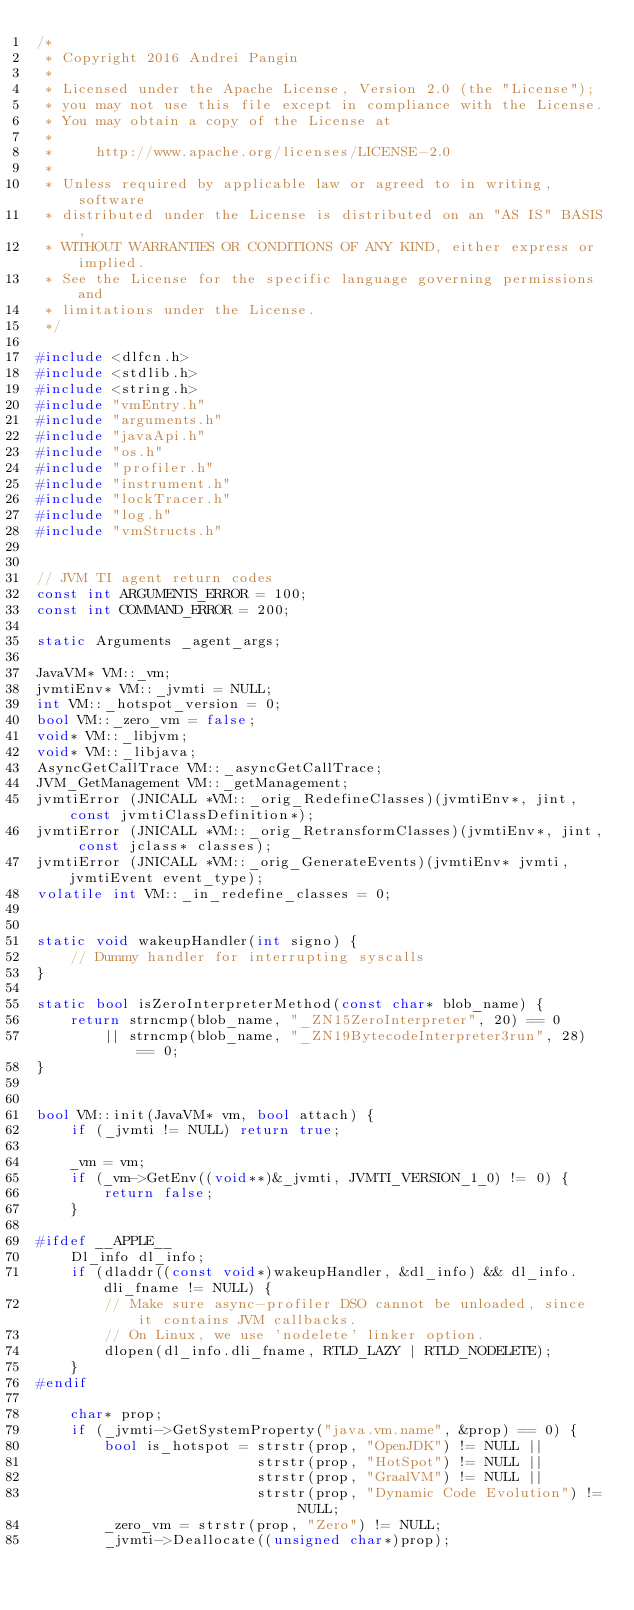Convert code to text. <code><loc_0><loc_0><loc_500><loc_500><_C++_>/*
 * Copyright 2016 Andrei Pangin
 *
 * Licensed under the Apache License, Version 2.0 (the "License");
 * you may not use this file except in compliance with the License.
 * You may obtain a copy of the License at
 *
 *     http://www.apache.org/licenses/LICENSE-2.0
 *
 * Unless required by applicable law or agreed to in writing, software
 * distributed under the License is distributed on an "AS IS" BASIS,
 * WITHOUT WARRANTIES OR CONDITIONS OF ANY KIND, either express or implied.
 * See the License for the specific language governing permissions and
 * limitations under the License.
 */

#include <dlfcn.h>
#include <stdlib.h>
#include <string.h>
#include "vmEntry.h"
#include "arguments.h"
#include "javaApi.h"
#include "os.h"
#include "profiler.h"
#include "instrument.h"
#include "lockTracer.h"
#include "log.h"
#include "vmStructs.h"


// JVM TI agent return codes
const int ARGUMENTS_ERROR = 100;
const int COMMAND_ERROR = 200;

static Arguments _agent_args;

JavaVM* VM::_vm;
jvmtiEnv* VM::_jvmti = NULL;
int VM::_hotspot_version = 0;
bool VM::_zero_vm = false;
void* VM::_libjvm;
void* VM::_libjava;
AsyncGetCallTrace VM::_asyncGetCallTrace;
JVM_GetManagement VM::_getManagement;
jvmtiError (JNICALL *VM::_orig_RedefineClasses)(jvmtiEnv*, jint, const jvmtiClassDefinition*);
jvmtiError (JNICALL *VM::_orig_RetransformClasses)(jvmtiEnv*, jint, const jclass* classes);
jvmtiError (JNICALL *VM::_orig_GenerateEvents)(jvmtiEnv* jvmti, jvmtiEvent event_type);
volatile int VM::_in_redefine_classes = 0;


static void wakeupHandler(int signo) {
    // Dummy handler for interrupting syscalls
}

static bool isZeroInterpreterMethod(const char* blob_name) {
    return strncmp(blob_name, "_ZN15ZeroInterpreter", 20) == 0
        || strncmp(blob_name, "_ZN19BytecodeInterpreter3run", 28) == 0;
}


bool VM::init(JavaVM* vm, bool attach) {
    if (_jvmti != NULL) return true;

    _vm = vm;
    if (_vm->GetEnv((void**)&_jvmti, JVMTI_VERSION_1_0) != 0) {
        return false;
    }

#ifdef __APPLE__
    Dl_info dl_info;
    if (dladdr((const void*)wakeupHandler, &dl_info) && dl_info.dli_fname != NULL) {
        // Make sure async-profiler DSO cannot be unloaded, since it contains JVM callbacks.
        // On Linux, we use 'nodelete' linker option.
        dlopen(dl_info.dli_fname, RTLD_LAZY | RTLD_NODELETE);
    }
#endif

    char* prop;
    if (_jvmti->GetSystemProperty("java.vm.name", &prop) == 0) {
        bool is_hotspot = strstr(prop, "OpenJDK") != NULL ||
                          strstr(prop, "HotSpot") != NULL ||
                          strstr(prop, "GraalVM") != NULL ||
                          strstr(prop, "Dynamic Code Evolution") != NULL;
        _zero_vm = strstr(prop, "Zero") != NULL;
        _jvmti->Deallocate((unsigned char*)prop);
</code> 